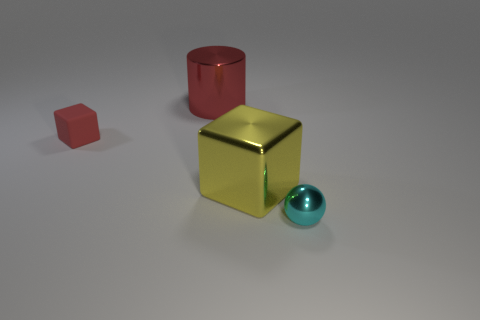Subtract all blue blocks. Subtract all cyan spheres. How many blocks are left? 2 Add 3 cyan metallic balls. How many objects exist? 7 Subtract all cylinders. How many objects are left? 3 Add 3 small red blocks. How many small red blocks are left? 4 Add 4 large matte cylinders. How many large matte cylinders exist? 4 Subtract 0 blue cylinders. How many objects are left? 4 Subtract all metal spheres. Subtract all small cubes. How many objects are left? 2 